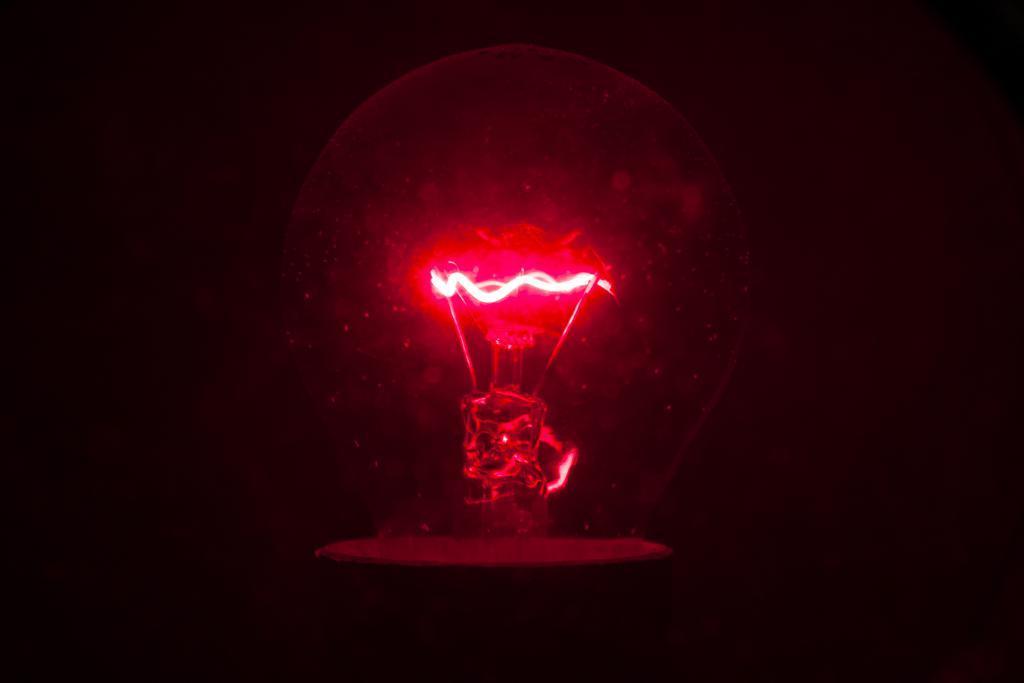How would you summarize this image in a sentence or two? In this image there is a bulb. In the background of the image it is dark. 